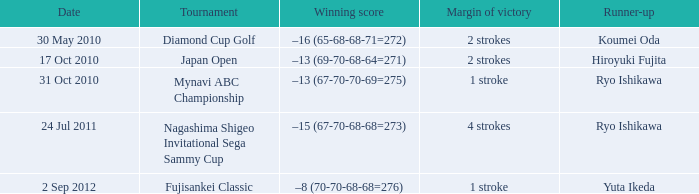Help me parse the entirety of this table. {'header': ['Date', 'Tournament', 'Winning score', 'Margin of victory', 'Runner-up'], 'rows': [['30 May 2010', 'Diamond Cup Golf', '–16 (65-68-68-71=272)', '2 strokes', 'Koumei Oda'], ['17 Oct 2010', 'Japan Open', '–13 (69-70-68-64=271)', '2 strokes', 'Hiroyuki Fujita'], ['31 Oct 2010', 'Mynavi ABC Championship', '–13 (67-70-70-69=275)', '1 stroke', 'Ryo Ishikawa'], ['24 Jul 2011', 'Nagashima Shigeo Invitational Sega Sammy Cup', '–15 (67-70-68-68=273)', '4 strokes', 'Ryo Ishikawa'], ['2 Sep 2012', 'Fujisankei Classic', '–8 (70-70-68-68=276)', '1 stroke', 'Yuta Ikeda']]} Who finished second in the japan open? Hiroyuki Fujita. 